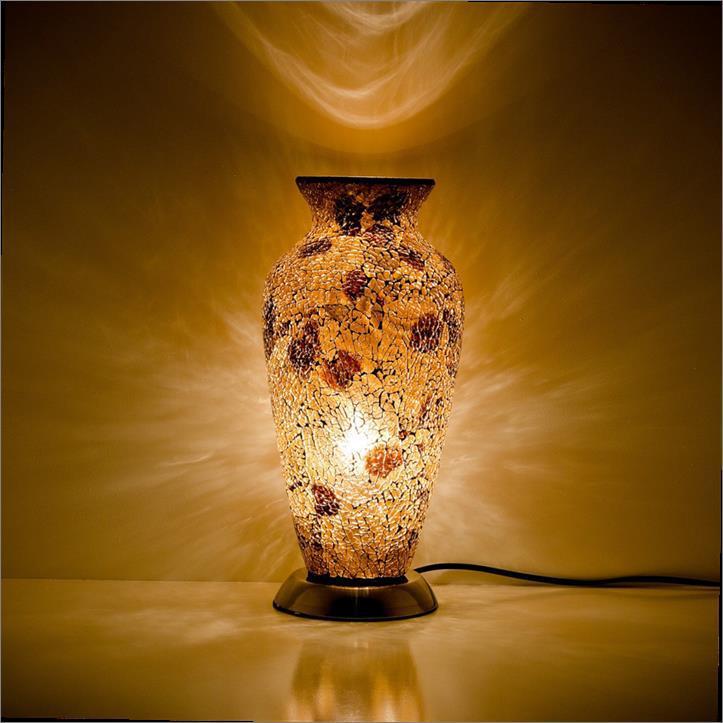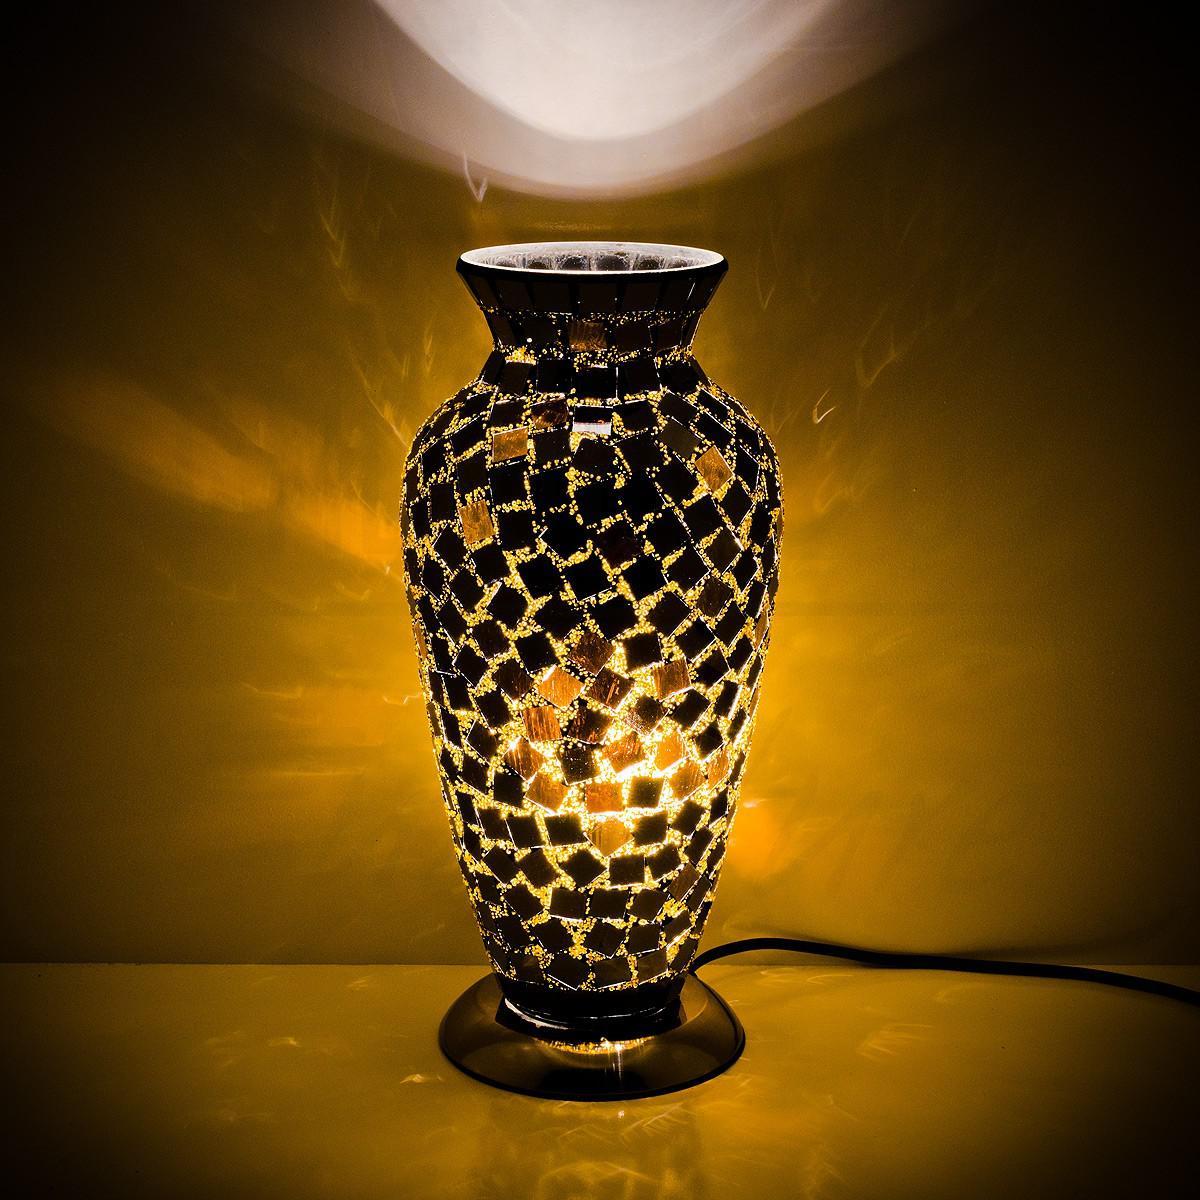The first image is the image on the left, the second image is the image on the right. For the images shown, is this caption "In both images, rays of light in the background appear to eminate from the vase." true? Answer yes or no. Yes. The first image is the image on the left, the second image is the image on the right. Analyze the images presented: Is the assertion "Both vases share the same shape." valid? Answer yes or no. Yes. 